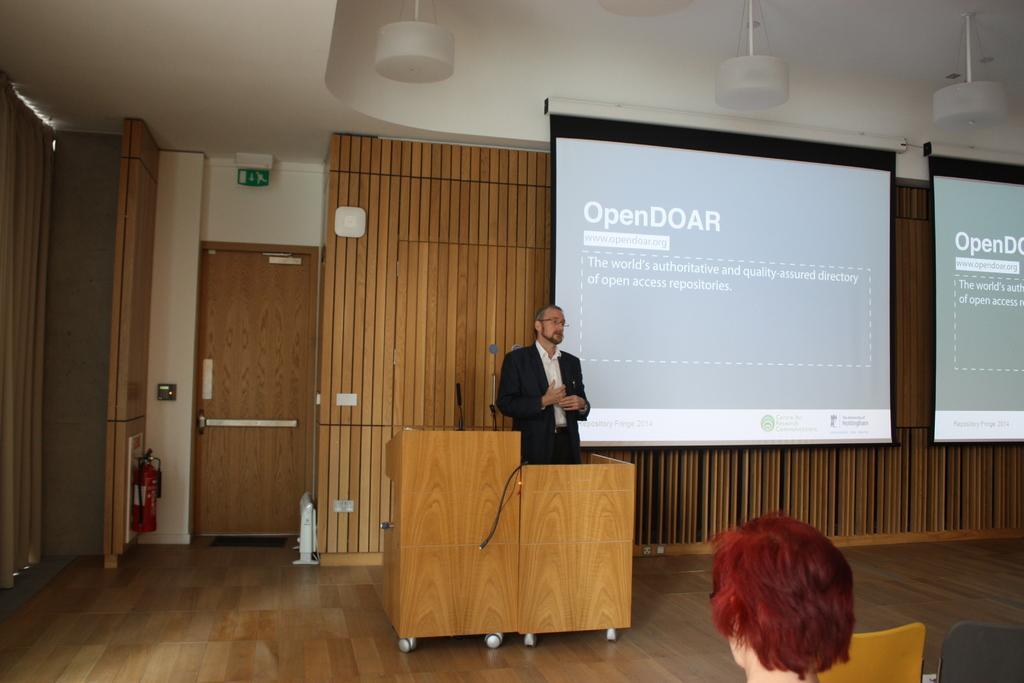Describe this image in one or two sentences. In this picture we can see a man standing at the podium on the floor and in front of him we can see a person, chairs and in the background we can see screens, wall, door, fire extinguisher, curtain, mic, signboard and some objects. 